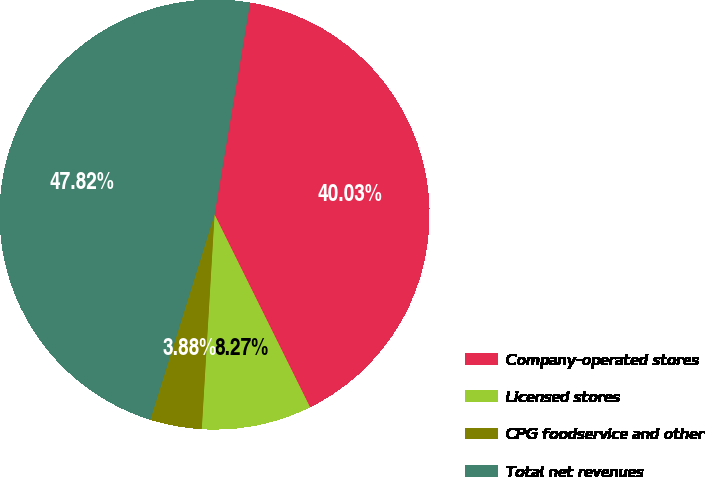Convert chart to OTSL. <chart><loc_0><loc_0><loc_500><loc_500><pie_chart><fcel>Company-operated stores<fcel>Licensed stores<fcel>CPG foodservice and other<fcel>Total net revenues<nl><fcel>40.03%<fcel>8.27%<fcel>3.88%<fcel>47.82%<nl></chart> 